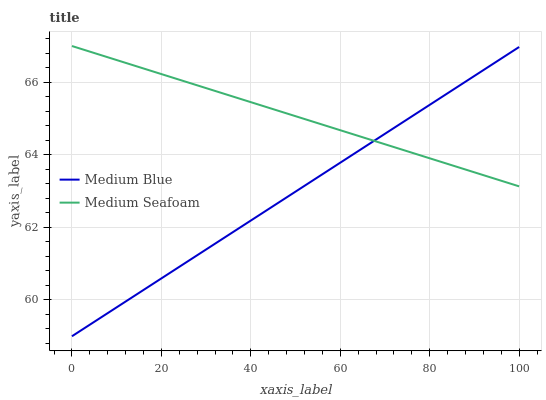Does Medium Blue have the minimum area under the curve?
Answer yes or no. Yes. Does Medium Seafoam have the maximum area under the curve?
Answer yes or no. Yes. Does Medium Seafoam have the minimum area under the curve?
Answer yes or no. No. Is Medium Seafoam the smoothest?
Answer yes or no. Yes. Is Medium Blue the roughest?
Answer yes or no. Yes. Is Medium Seafoam the roughest?
Answer yes or no. No. Does Medium Blue have the lowest value?
Answer yes or no. Yes. Does Medium Seafoam have the lowest value?
Answer yes or no. No. Does Medium Seafoam have the highest value?
Answer yes or no. Yes. Does Medium Seafoam intersect Medium Blue?
Answer yes or no. Yes. Is Medium Seafoam less than Medium Blue?
Answer yes or no. No. Is Medium Seafoam greater than Medium Blue?
Answer yes or no. No. 